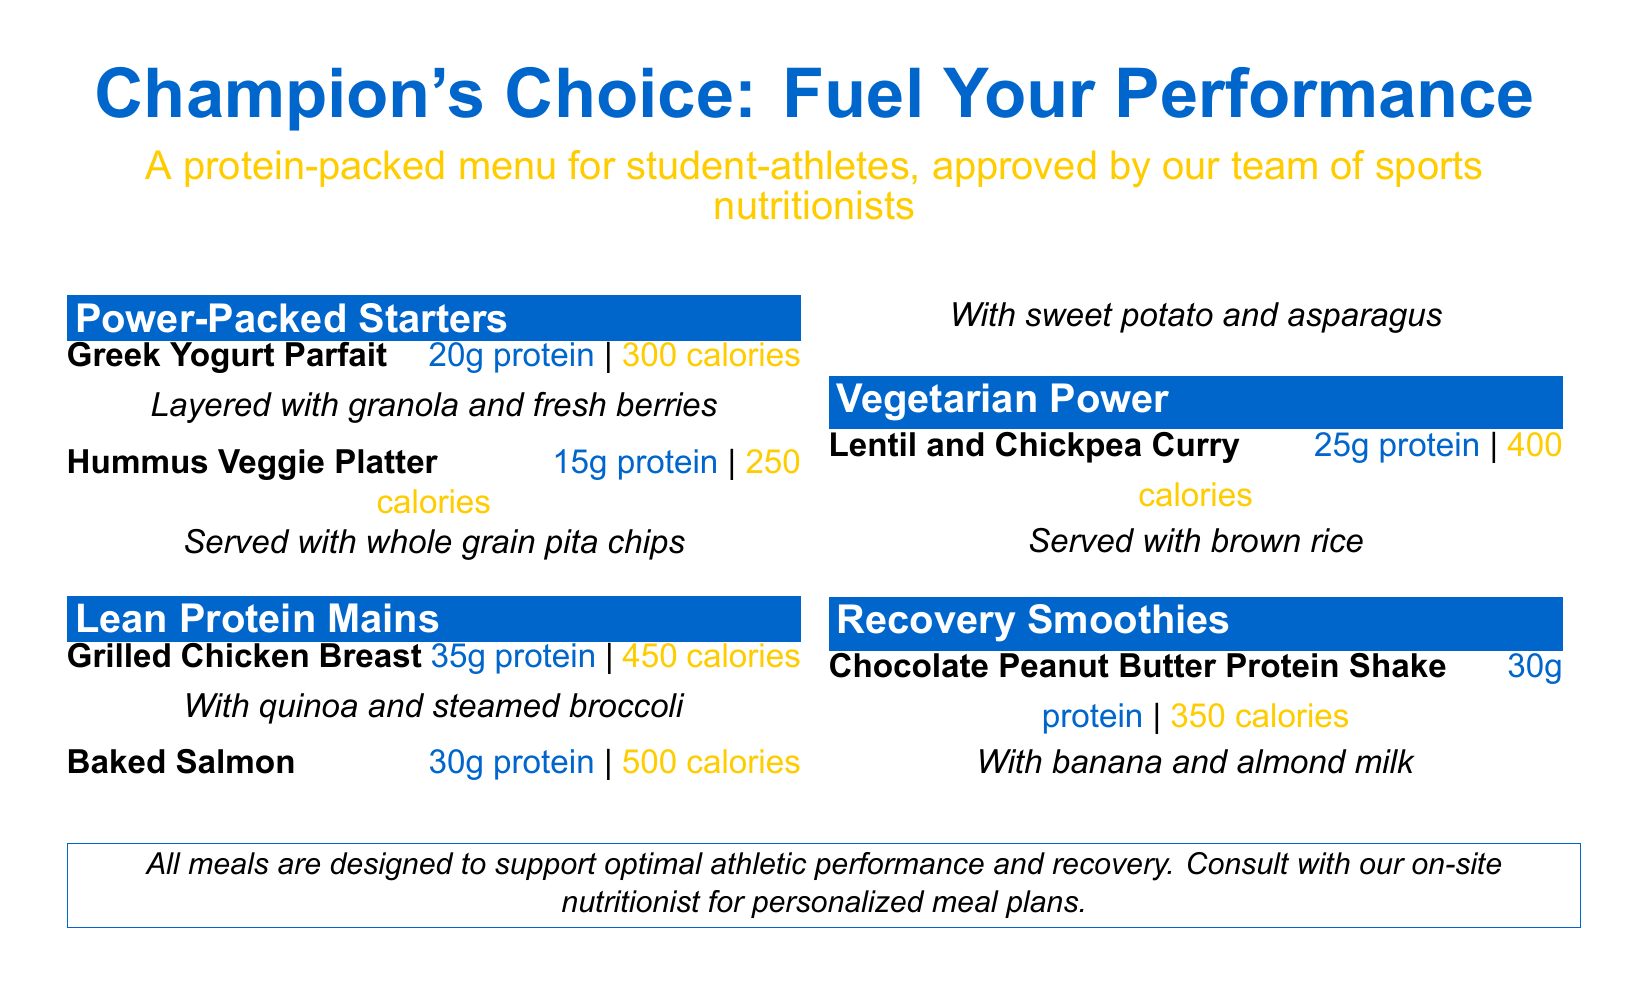What is the protein content of the Greek Yogurt Parfait? The document states that the Greek Yogurt Parfait contains 20g of protein.
Answer: 20g How many calories are in the Baked Salmon? The document lists the Baked Salmon as having 500 calories.
Answer: 500 What is served with the Hummus Veggie Platter? According to the menu, the Hummus Veggie Platter is served with whole grain pita chips.
Answer: whole grain pita chips What is the protein content of the Recovery Smoothie? The Chocolate Peanut Butter Protein Shake features 30g of protein according to the document.
Answer: 30g Which meal in the menu has the highest calorie count? The document shows that the Baked Salmon has the highest caloric content at 500 calories.
Answer: Baked Salmon How many protein-packed starters are listed? The menu includes two items in the Power-Packed Starters section.
Answer: 2 What vegetarian option is available? The document details that the Lentil and Chickpea Curry is the vegetarian option available.
Answer: Lentil and Chickpea Curry Which dish contains quinoa? The Grilled Chicken Breast is accompanied by quinoa as mentioned in the document.
Answer: Grilled Chicken Breast What nutritional consultation is offered? The menu states that there is an opportunity to consult with the on-site nutritionist for personalized meal plans.
Answer: on-site nutritionist 